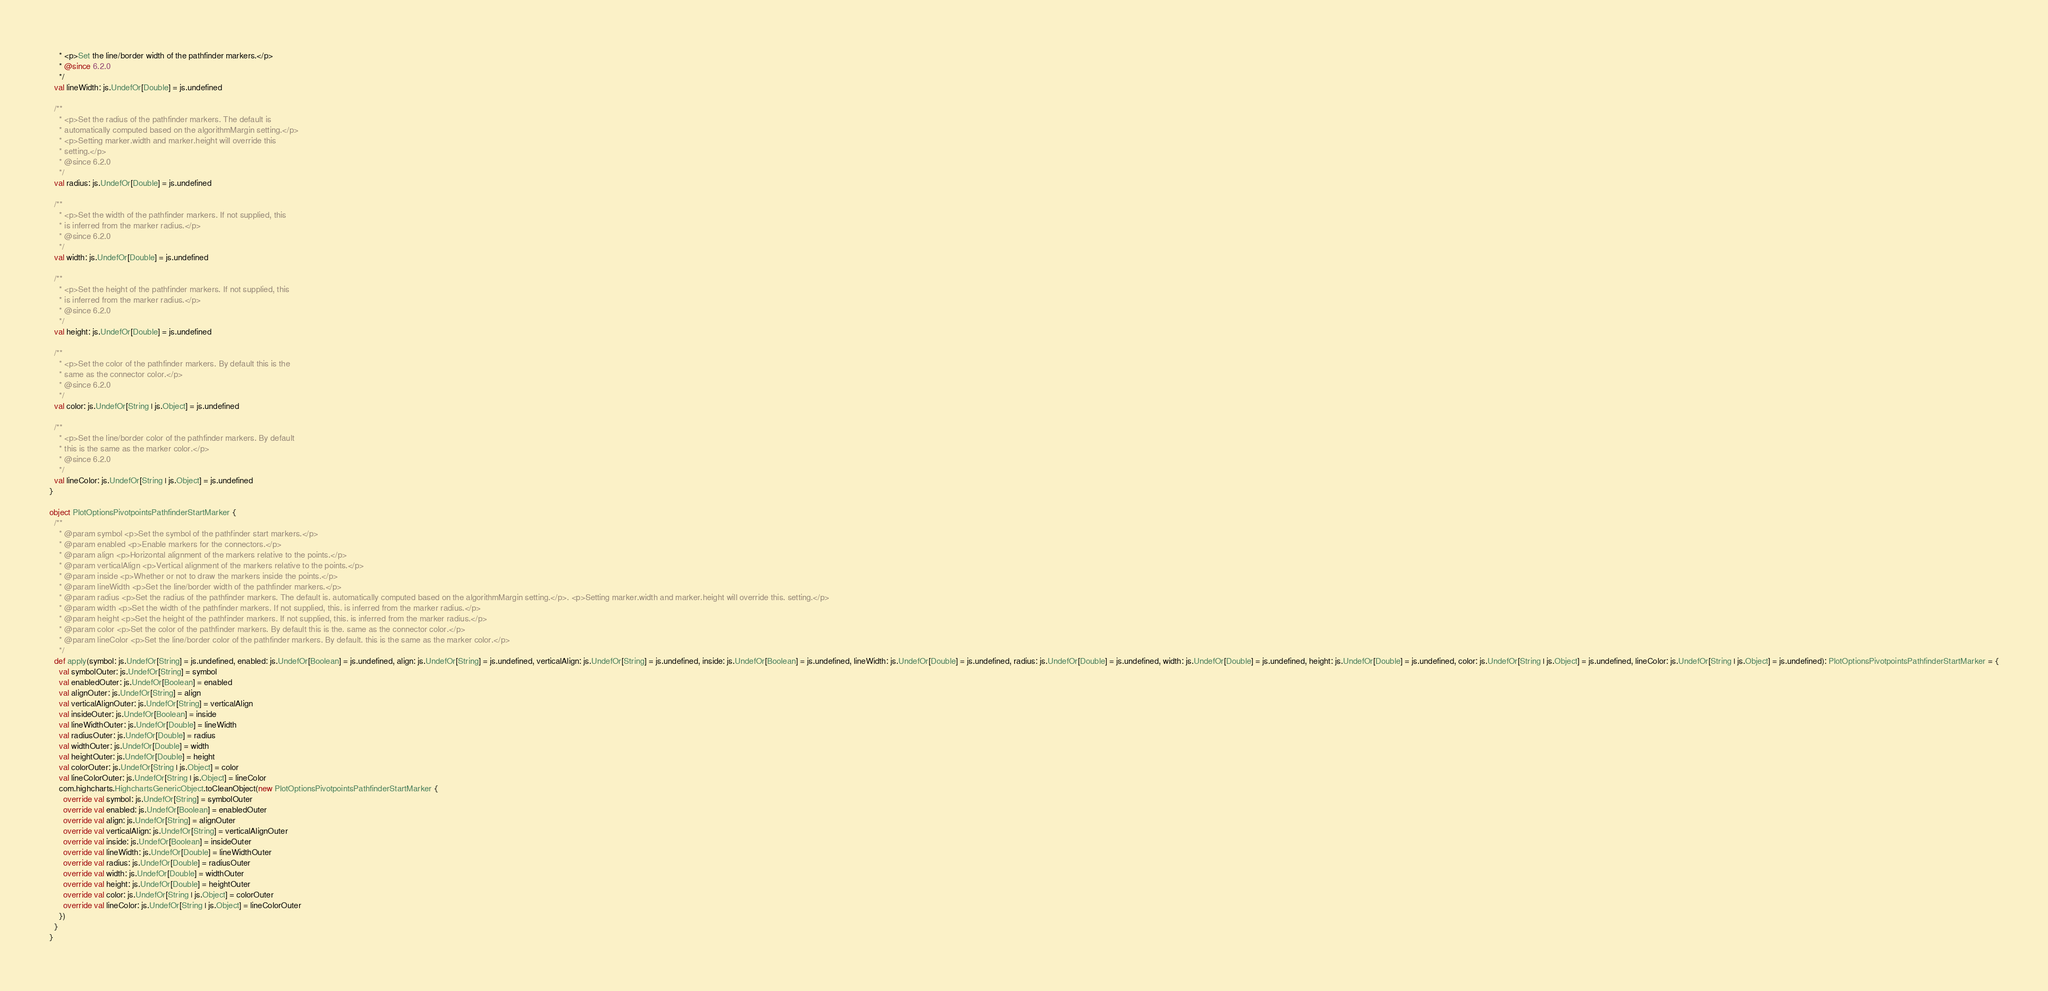<code> <loc_0><loc_0><loc_500><loc_500><_Scala_>    * <p>Set the line/border width of the pathfinder markers.</p>
    * @since 6.2.0
    */
  val lineWidth: js.UndefOr[Double] = js.undefined

  /**
    * <p>Set the radius of the pathfinder markers. The default is
    * automatically computed based on the algorithmMargin setting.</p>
    * <p>Setting marker.width and marker.height will override this
    * setting.</p>
    * @since 6.2.0
    */
  val radius: js.UndefOr[Double] = js.undefined

  /**
    * <p>Set the width of the pathfinder markers. If not supplied, this
    * is inferred from the marker radius.</p>
    * @since 6.2.0
    */
  val width: js.UndefOr[Double] = js.undefined

  /**
    * <p>Set the height of the pathfinder markers. If not supplied, this
    * is inferred from the marker radius.</p>
    * @since 6.2.0
    */
  val height: js.UndefOr[Double] = js.undefined

  /**
    * <p>Set the color of the pathfinder markers. By default this is the
    * same as the connector color.</p>
    * @since 6.2.0
    */
  val color: js.UndefOr[String | js.Object] = js.undefined

  /**
    * <p>Set the line/border color of the pathfinder markers. By default
    * this is the same as the marker color.</p>
    * @since 6.2.0
    */
  val lineColor: js.UndefOr[String | js.Object] = js.undefined
}

object PlotOptionsPivotpointsPathfinderStartMarker {
  /**
    * @param symbol <p>Set the symbol of the pathfinder start markers.</p>
    * @param enabled <p>Enable markers for the connectors.</p>
    * @param align <p>Horizontal alignment of the markers relative to the points.</p>
    * @param verticalAlign <p>Vertical alignment of the markers relative to the points.</p>
    * @param inside <p>Whether or not to draw the markers inside the points.</p>
    * @param lineWidth <p>Set the line/border width of the pathfinder markers.</p>
    * @param radius <p>Set the radius of the pathfinder markers. The default is. automatically computed based on the algorithmMargin setting.</p>. <p>Setting marker.width and marker.height will override this. setting.</p>
    * @param width <p>Set the width of the pathfinder markers. If not supplied, this. is inferred from the marker radius.</p>
    * @param height <p>Set the height of the pathfinder markers. If not supplied, this. is inferred from the marker radius.</p>
    * @param color <p>Set the color of the pathfinder markers. By default this is the. same as the connector color.</p>
    * @param lineColor <p>Set the line/border color of the pathfinder markers. By default. this is the same as the marker color.</p>
    */
  def apply(symbol: js.UndefOr[String] = js.undefined, enabled: js.UndefOr[Boolean] = js.undefined, align: js.UndefOr[String] = js.undefined, verticalAlign: js.UndefOr[String] = js.undefined, inside: js.UndefOr[Boolean] = js.undefined, lineWidth: js.UndefOr[Double] = js.undefined, radius: js.UndefOr[Double] = js.undefined, width: js.UndefOr[Double] = js.undefined, height: js.UndefOr[Double] = js.undefined, color: js.UndefOr[String | js.Object] = js.undefined, lineColor: js.UndefOr[String | js.Object] = js.undefined): PlotOptionsPivotpointsPathfinderStartMarker = {
    val symbolOuter: js.UndefOr[String] = symbol
    val enabledOuter: js.UndefOr[Boolean] = enabled
    val alignOuter: js.UndefOr[String] = align
    val verticalAlignOuter: js.UndefOr[String] = verticalAlign
    val insideOuter: js.UndefOr[Boolean] = inside
    val lineWidthOuter: js.UndefOr[Double] = lineWidth
    val radiusOuter: js.UndefOr[Double] = radius
    val widthOuter: js.UndefOr[Double] = width
    val heightOuter: js.UndefOr[Double] = height
    val colorOuter: js.UndefOr[String | js.Object] = color
    val lineColorOuter: js.UndefOr[String | js.Object] = lineColor
    com.highcharts.HighchartsGenericObject.toCleanObject(new PlotOptionsPivotpointsPathfinderStartMarker {
      override val symbol: js.UndefOr[String] = symbolOuter
      override val enabled: js.UndefOr[Boolean] = enabledOuter
      override val align: js.UndefOr[String] = alignOuter
      override val verticalAlign: js.UndefOr[String] = verticalAlignOuter
      override val inside: js.UndefOr[Boolean] = insideOuter
      override val lineWidth: js.UndefOr[Double] = lineWidthOuter
      override val radius: js.UndefOr[Double] = radiusOuter
      override val width: js.UndefOr[Double] = widthOuter
      override val height: js.UndefOr[Double] = heightOuter
      override val color: js.UndefOr[String | js.Object] = colorOuter
      override val lineColor: js.UndefOr[String | js.Object] = lineColorOuter
    })
  }
}
</code> 